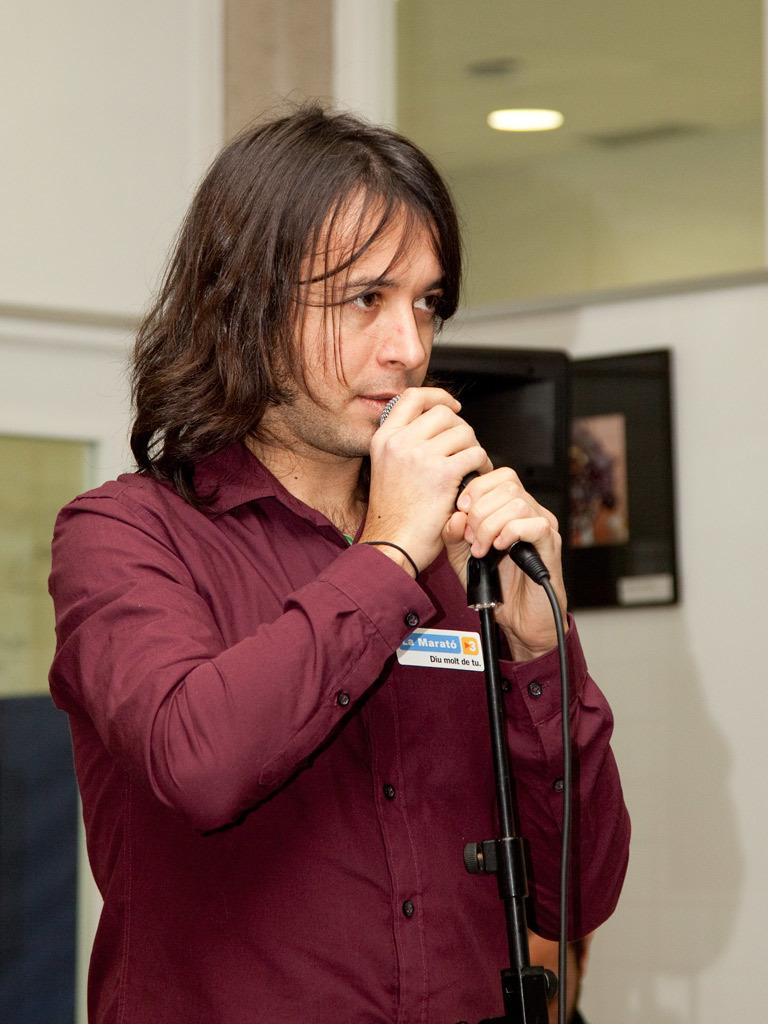Where was the image taken? The image is taken in a room. What is the man in the image doing? The man is talking into a microphone. What is the man wearing in the image? The man is wearing a brown shirt. What can be seen in the background of the image? There is a wall in the background of the image. What type of market can be seen in the image? There is no market present in the image; it is a room with a man talking into a microphone. What is on the front of the man's shirt in the image? The provided facts do not mention any specific design or feature on the front of the man's shirt, only its color (brown). 